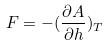<formula> <loc_0><loc_0><loc_500><loc_500>F = - ( \frac { \partial A } { \partial h } ) _ { T }</formula> 